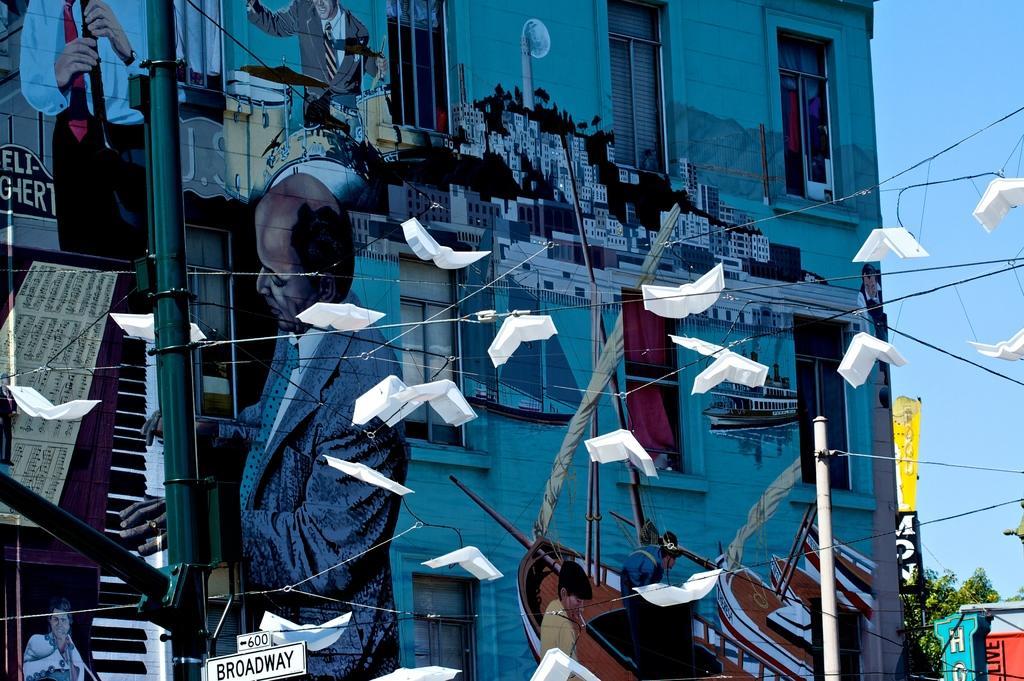Could you give a brief overview of what you see in this image? In this image I can see few poles, few boards, number of wires and on it I can see number of white colour things. In the background I can see few buildings, few trees, the sky and I can also see painting on the building. 